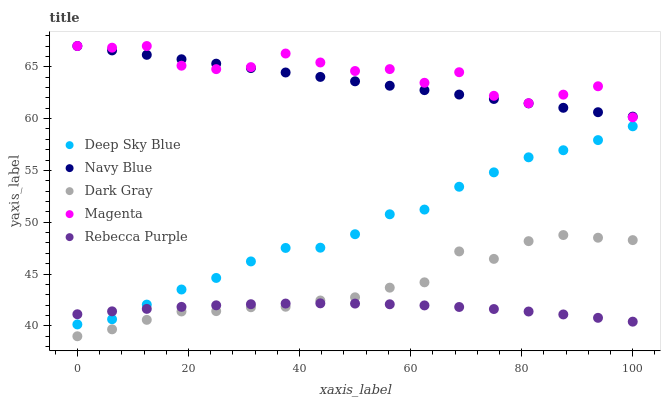Does Rebecca Purple have the minimum area under the curve?
Answer yes or no. Yes. Does Magenta have the maximum area under the curve?
Answer yes or no. Yes. Does Navy Blue have the minimum area under the curve?
Answer yes or no. No. Does Navy Blue have the maximum area under the curve?
Answer yes or no. No. Is Navy Blue the smoothest?
Answer yes or no. Yes. Is Magenta the roughest?
Answer yes or no. Yes. Is Magenta the smoothest?
Answer yes or no. No. Is Navy Blue the roughest?
Answer yes or no. No. Does Dark Gray have the lowest value?
Answer yes or no. Yes. Does Magenta have the lowest value?
Answer yes or no. No. Does Magenta have the highest value?
Answer yes or no. Yes. Does Rebecca Purple have the highest value?
Answer yes or no. No. Is Dark Gray less than Deep Sky Blue?
Answer yes or no. Yes. Is Magenta greater than Rebecca Purple?
Answer yes or no. Yes. Does Rebecca Purple intersect Deep Sky Blue?
Answer yes or no. Yes. Is Rebecca Purple less than Deep Sky Blue?
Answer yes or no. No. Is Rebecca Purple greater than Deep Sky Blue?
Answer yes or no. No. Does Dark Gray intersect Deep Sky Blue?
Answer yes or no. No. 